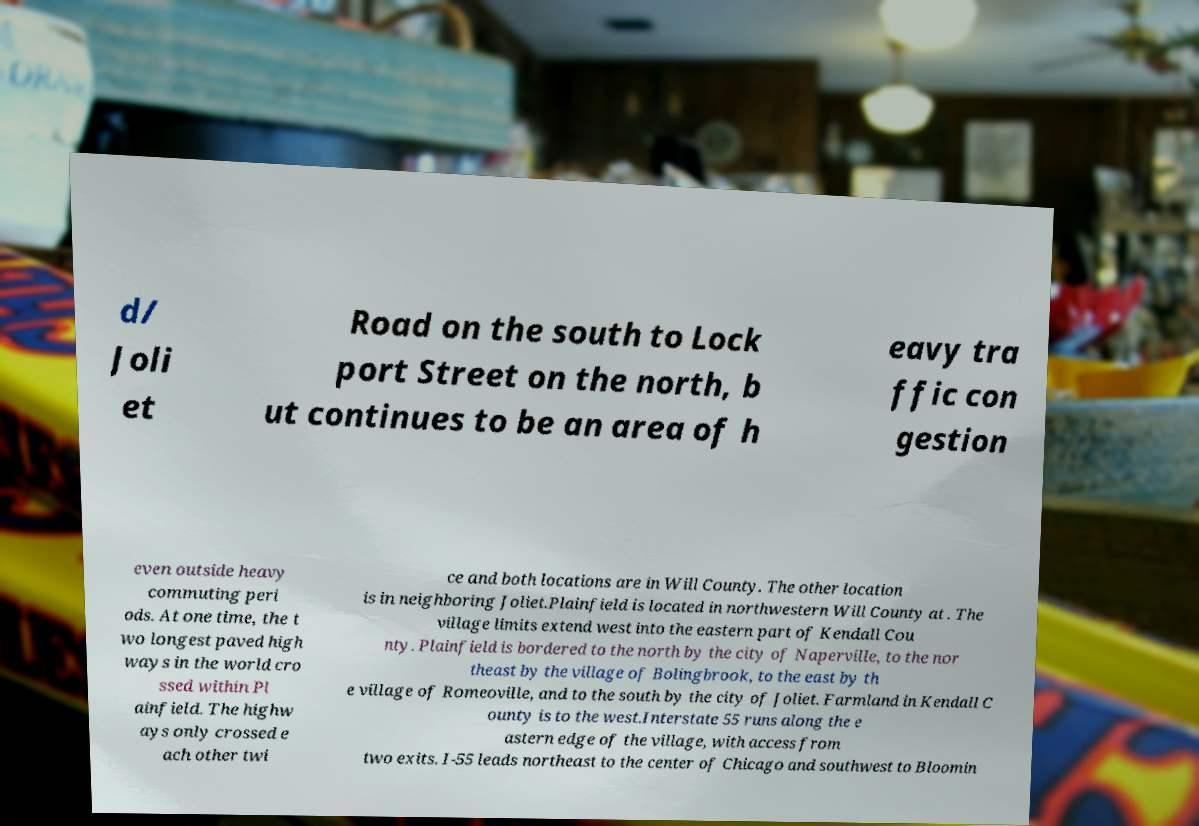Please read and relay the text visible in this image. What does it say? d/ Joli et Road on the south to Lock port Street on the north, b ut continues to be an area of h eavy tra ffic con gestion even outside heavy commuting peri ods. At one time, the t wo longest paved high ways in the world cro ssed within Pl ainfield. The highw ays only crossed e ach other twi ce and both locations are in Will County. The other location is in neighboring Joliet.Plainfield is located in northwestern Will County at . The village limits extend west into the eastern part of Kendall Cou nty. Plainfield is bordered to the north by the city of Naperville, to the nor theast by the village of Bolingbrook, to the east by th e village of Romeoville, and to the south by the city of Joliet. Farmland in Kendall C ounty is to the west.Interstate 55 runs along the e astern edge of the village, with access from two exits. I-55 leads northeast to the center of Chicago and southwest to Bloomin 